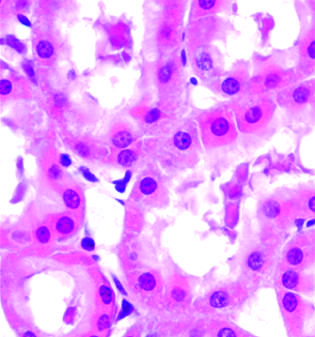does early ischemic injury show surface blebs, increase eosinophilia of cytoplasm, and swelling of occasional cells?
Answer the question using a single word or phrase. Yes 